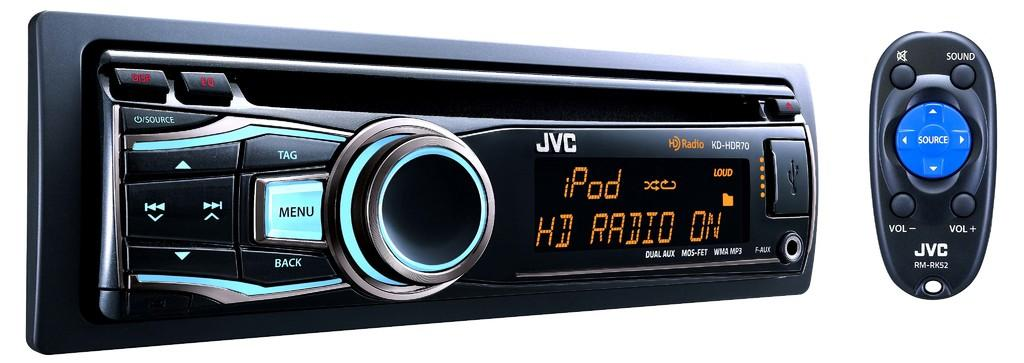Provide a one-sentence caption for the provided image. A JVC KD HDR70 Radio receiver with remote. 